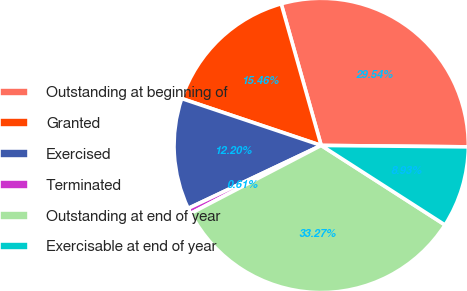Convert chart. <chart><loc_0><loc_0><loc_500><loc_500><pie_chart><fcel>Outstanding at beginning of<fcel>Granted<fcel>Exercised<fcel>Terminated<fcel>Outstanding at end of year<fcel>Exercisable at end of year<nl><fcel>29.54%<fcel>15.46%<fcel>12.2%<fcel>0.61%<fcel>33.27%<fcel>8.93%<nl></chart> 